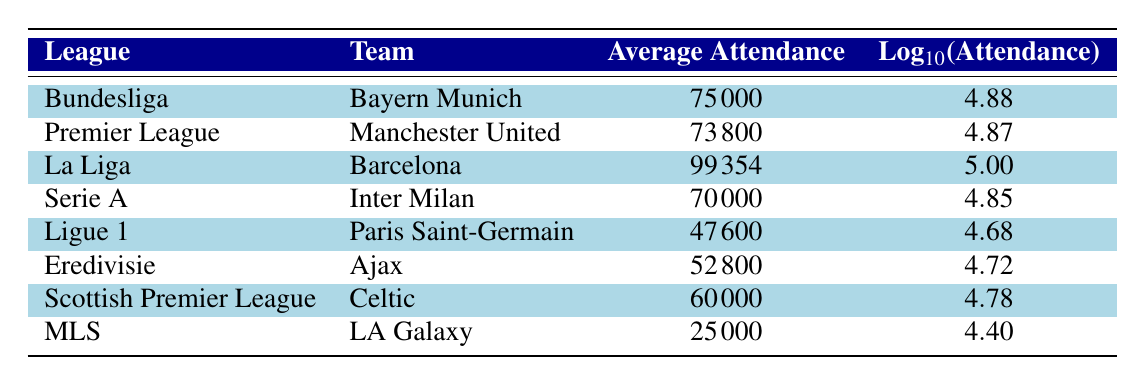What is the average attendance for Bayern Munich? The table shows the average attendance for Bayern Munich listed under the Bundesliga, which is 75000.
Answer: 75000 Which team has the highest average attendance? The table lists Barcelona under La Liga with the highest average attendance of 99354.
Answer: Barcelona What is the average attendance difference between Manchester United and LA Galaxy? The average attendance for Manchester United is 73800, and LA Galaxy is 25000. The difference is 73800 - 25000 = 48800.
Answer: 48800 Is the average attendance for Paris Saint-Germain greater than 50000? The average attendance for Paris Saint-Germain is shown as 47600, which is less than 50000.
Answer: No Which league has the lowest average attendance? By comparing the average attendance figures in the table, MLS has the lowest average attendance of 25000.
Answer: MLS What is the total average attendance for all teams listed in the table? The total can be calculated by summing the average attendance figures: 75000 + 73800 + 99354 + 70000 + 47600 + 52800 + 60000 + 25000 = 403554.
Answer: 403554 Which team has an average attendance of 60000? The table states that Celtic, from the Scottish Premier League, has an average attendance of 60000.
Answer: Celtic If we consider only the top three teams by attendance, what is their average attendance? The top three teams are Barcelona (99354), Bayern Munich (75000), and Manchester United (73800). The average attendance is (99354 + 75000 + 73800) / 3 = 82718.
Answer: 82718 Does Inter Milan have a higher average attendance than Ajax? Inter Milan's average attendance is 70000, while Ajax's is 52800, so yes, Inter Milan has a higher attendance.
Answer: Yes 